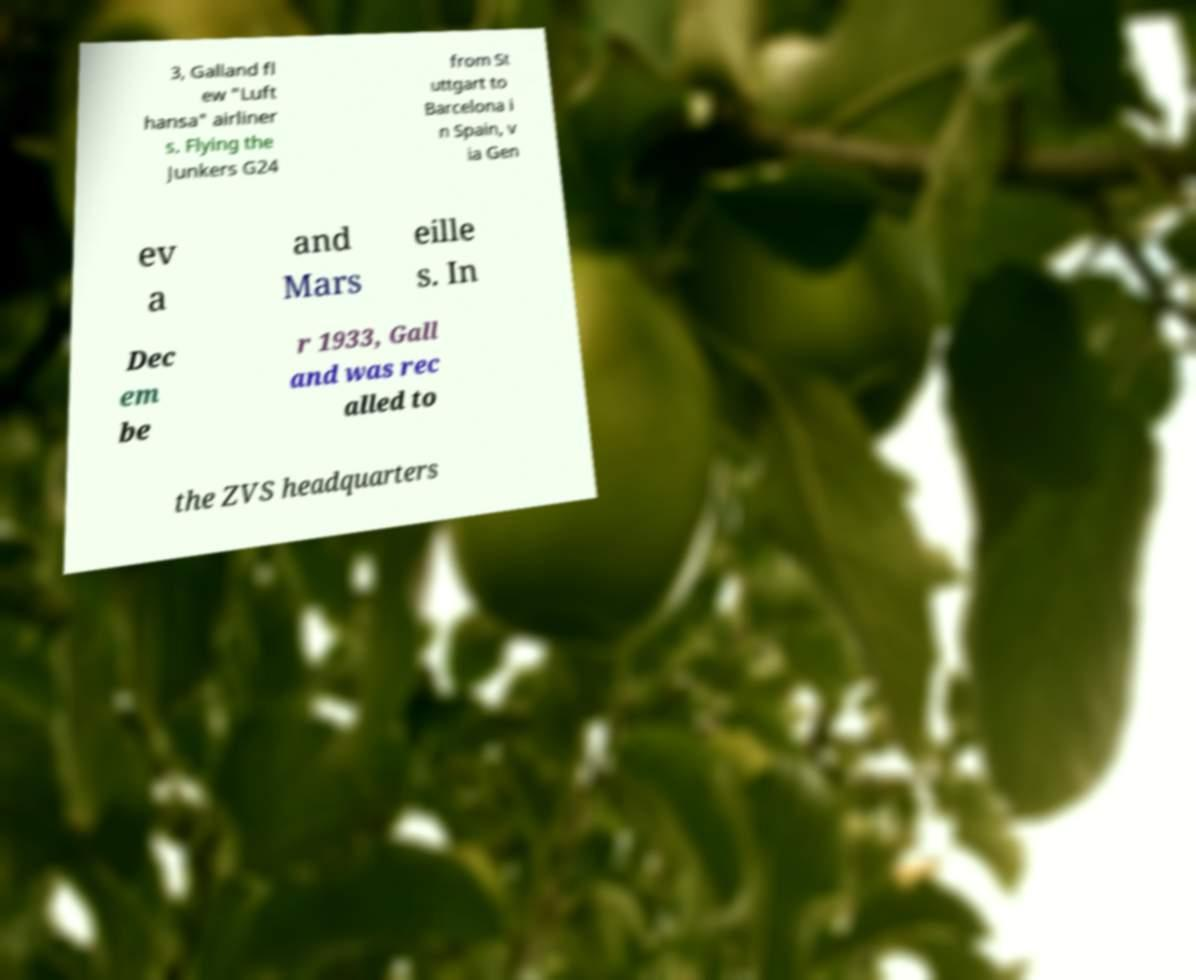I need the written content from this picture converted into text. Can you do that? 3, Galland fl ew "Luft hansa" airliner s. Flying the Junkers G24 from St uttgart to Barcelona i n Spain, v ia Gen ev a and Mars eille s. In Dec em be r 1933, Gall and was rec alled to the ZVS headquarters 